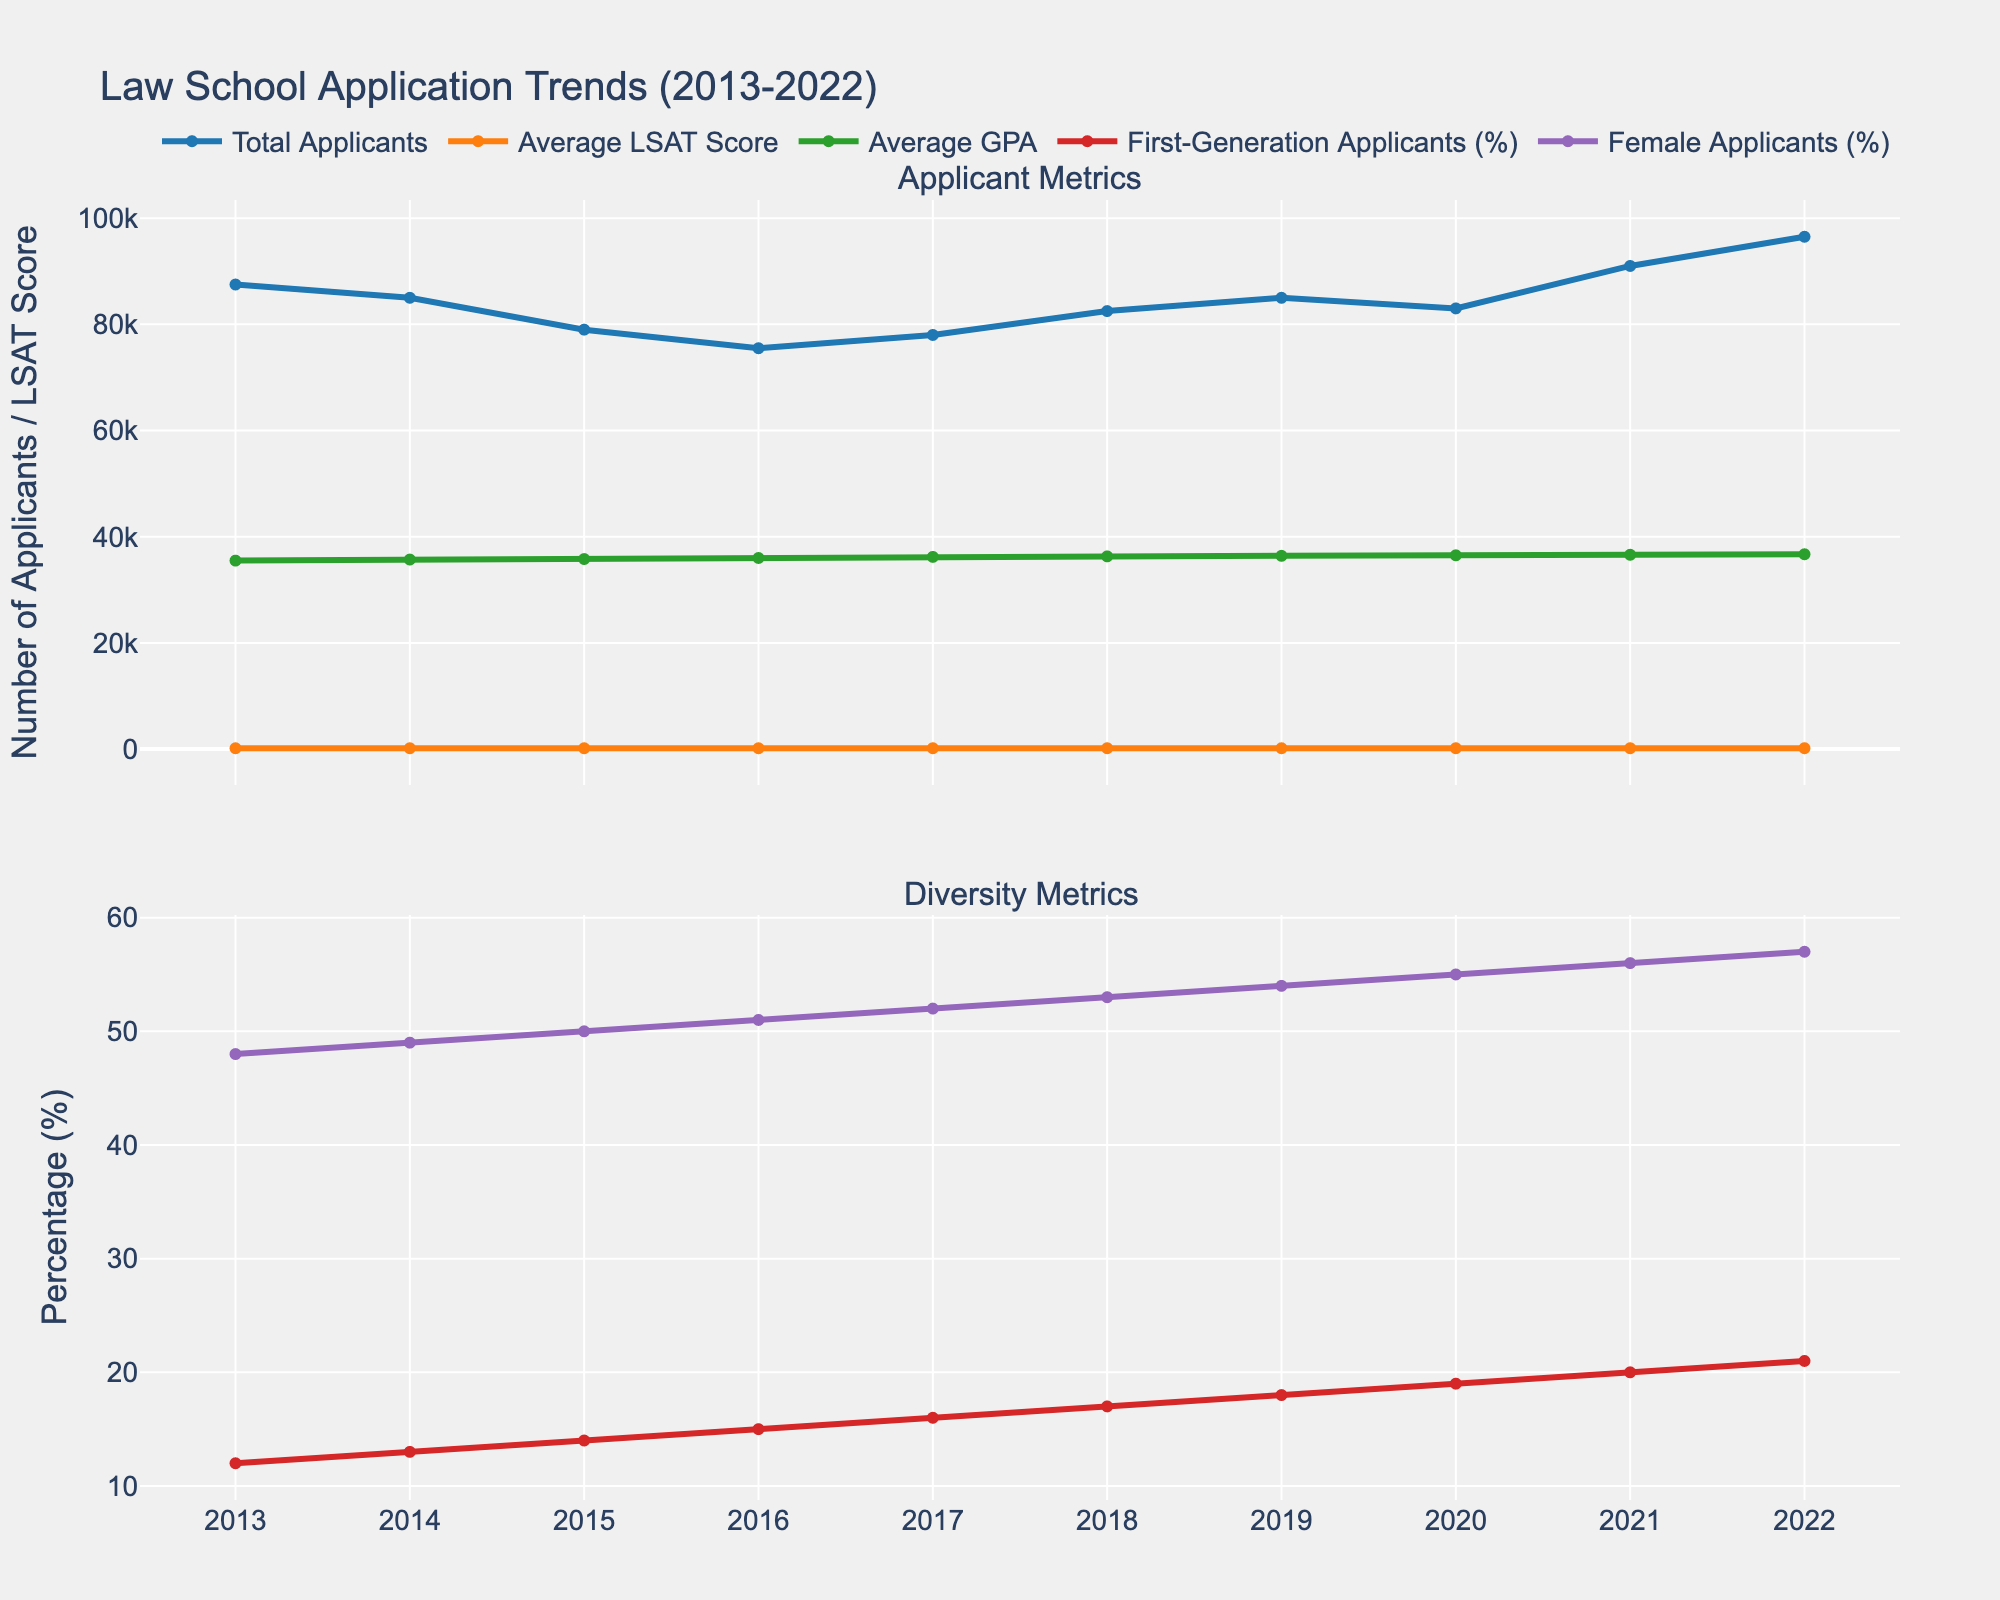what is the trend for the total number of applicants between 2013 and 2022? To identify the trend for the total number of applicants, observe the line representing the 'Total Applicants' from 2013 to 2022. The line starts high, dipping slightly from 2013 to 2015, then gradually increasing with a significant rise after 2019, reaching its peak in 2022.
Answer: Increasing trend How has the average LSAT score changed from 2013 to 2022? The line representing the 'Average LSAT Score' shows a steady increase from 162 in 2013 to 170 in 2022. No sharp rises or drops are noticed, indicating a consistent upward trend.
Answer: Steadily increased Which year had the highest percentage of female applicants? The line representing 'Female Applicants (%)' peaks at its highest point in 2022, indicating that 2022 had the highest percentage of female applicants.
Answer: 2022 What is the difference in total applicants between the year with the highest and the lowest number of applicants? Referring to the 'Total Applicants' line, the highest number of applicants is 96500 in 2022, and the lowest is 75500 in 2016. The difference is 96500 - 75500 = 21000.
Answer: 21000 Between which years did first-generation applicants see the greatest increase in percentage? The line for 'First-Generation Applicants (%)' shows the steepest climb between 2018 and 2019 where it jumps from 17% to 18%.
Answer: 2018 to 2019 Did the average GPA have a consistent trend, and what was the initial and final value? The line for 'Average GPA' is scaled up for visibility, showing a consistent upward trend. Initially, it's 3.55 in 2013, and finally, it is 3.67 in 2022.
Answer: Consistent upward, 3.55 and 3.67 How does the percentage of female applicants in 2017 compare to that in 2013? In 2017, the percentage of female applicants is 52%, while in 2013 it is 48%. Subtracting the two gives 52% - 48% = 4%.
Answer: 4% higher in 2017 How much did the average LSAT score increase from the year with the lowest average GPA to the year with the highest average GPA? The lowest average GPA is in 2013 (3.55), and the highest is in 2022 (3.67). The corresponding LSAT scores are 162 and 170, respectively. The increase is 170 - 162 = 8.
Answer: 8 Which metric shows more variability: First-generation applicants (%) or average GPA? The visual variability in 'First-Generation Applicants (%)' line is more pronounced compared to the 'Average GPA' line, which shows a more linear progression.
Answer: First-generation applicants (%) What year did the average LSAT score reach 167? By observing the 'Average LSAT Score' line, it reached 167 in 2018 and remained the same in 2019.
Answer: 2018 